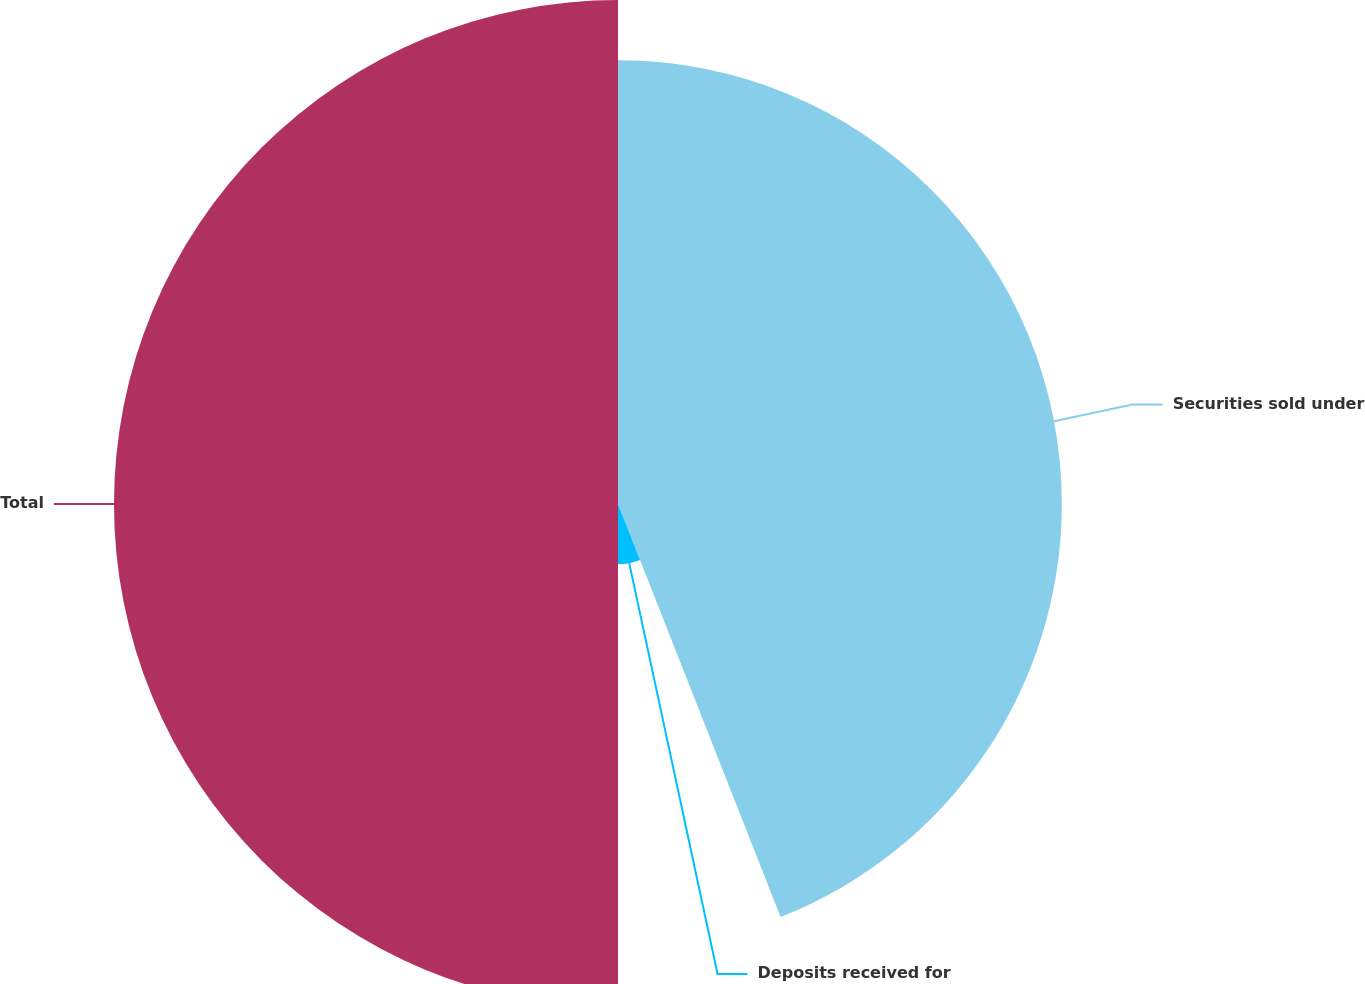Convert chart to OTSL. <chart><loc_0><loc_0><loc_500><loc_500><pie_chart><fcel>Securities sold under<fcel>Deposits received for<fcel>Total<nl><fcel>44.03%<fcel>5.97%<fcel>50.0%<nl></chart> 